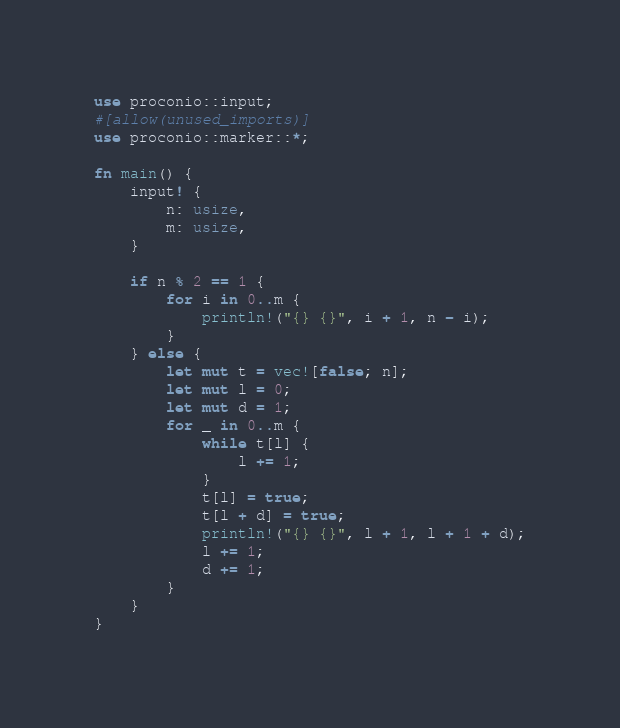<code> <loc_0><loc_0><loc_500><loc_500><_Rust_>use proconio::input;
#[allow(unused_imports)]
use proconio::marker::*;

fn main() {
    input! {
        n: usize,
        m: usize,
    }

    if n % 2 == 1 {
        for i in 0..m {
            println!("{} {}", i + 1, n - i);
        }
    } else {
        let mut t = vec![false; n];
        let mut l = 0;
        let mut d = 1;
        for _ in 0..m {
            while t[l] {
                l += 1;
            }
            t[l] = true;
            t[l + d] = true;
            println!("{} {}", l + 1, l + 1 + d);
            l += 1;
            d += 1;
        }
    }
}
</code> 